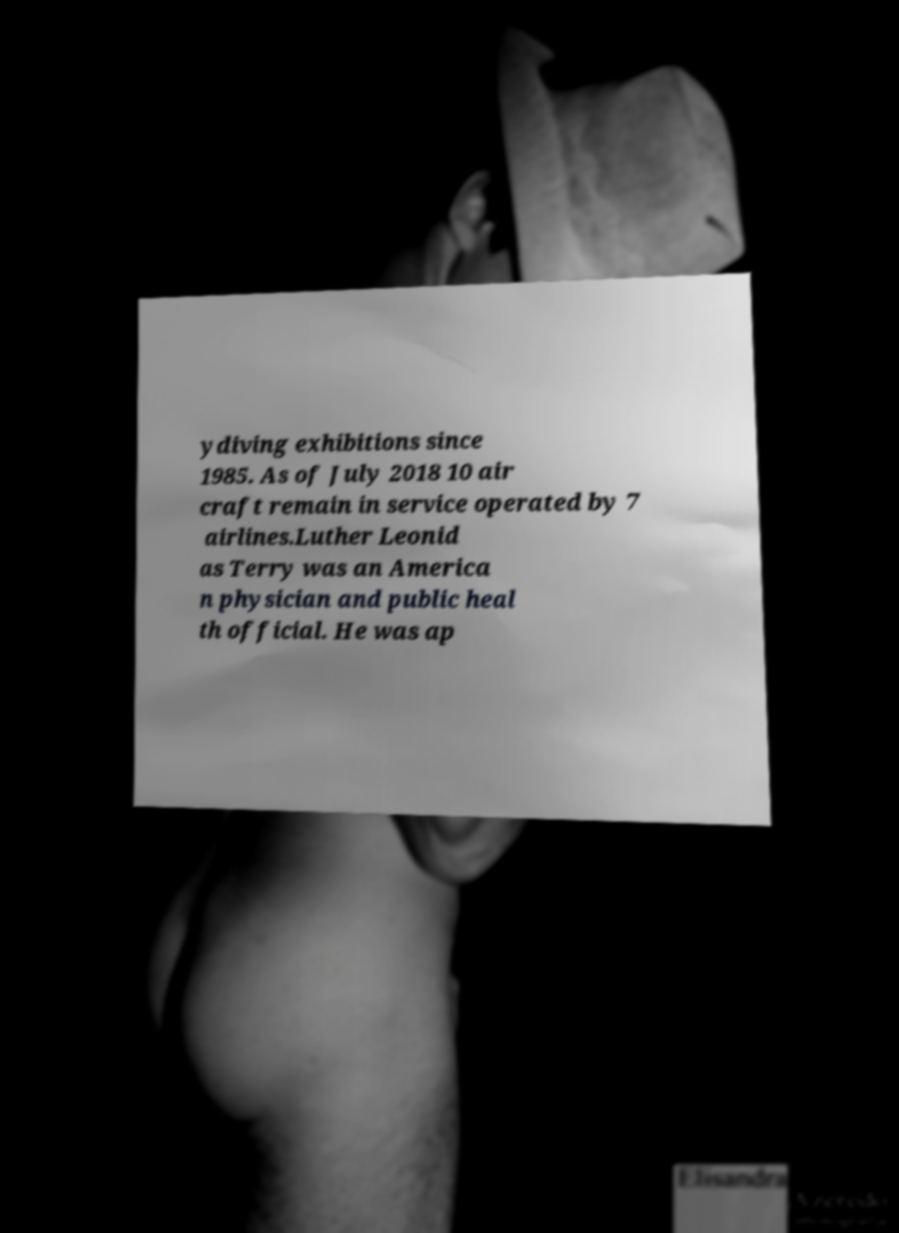Please read and relay the text visible in this image. What does it say? ydiving exhibitions since 1985. As of July 2018 10 air craft remain in service operated by 7 airlines.Luther Leonid as Terry was an America n physician and public heal th official. He was ap 